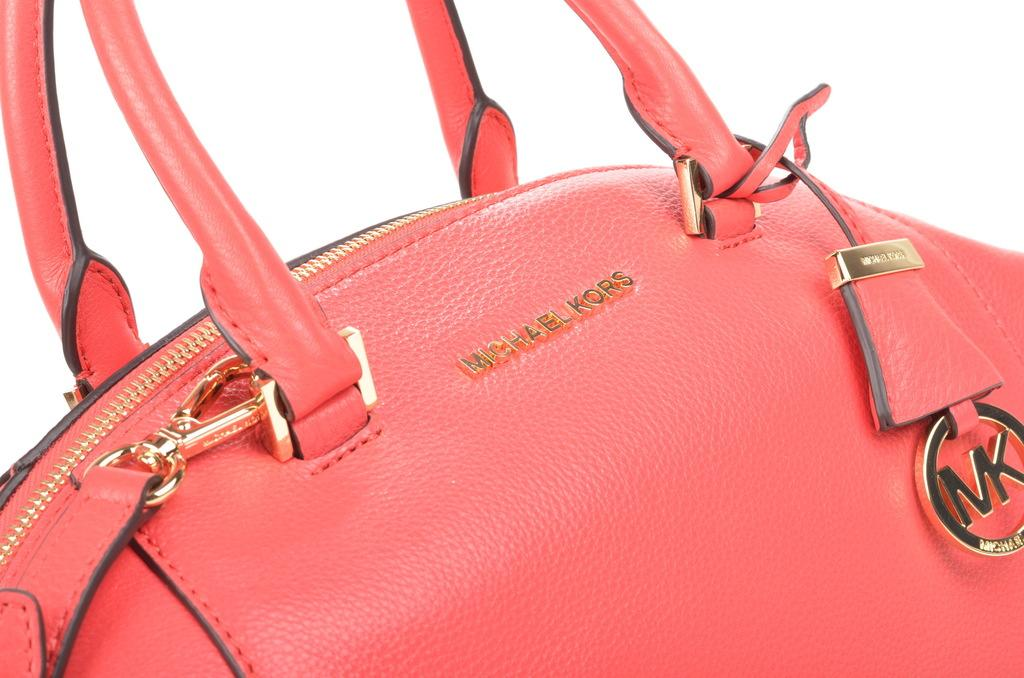What type of accessory is present in the image? There is a red handbag in the image. Are there any letters or initials visible in the image? Yes, the initials "MK" are visible in the image. What type of story is being told by the cattle in the image? There are no cattle present in the image, so no story can be told by them. 